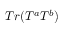Convert formula to latex. <formula><loc_0><loc_0><loc_500><loc_500>T r ( T ^ { a } T ^ { b } )</formula> 